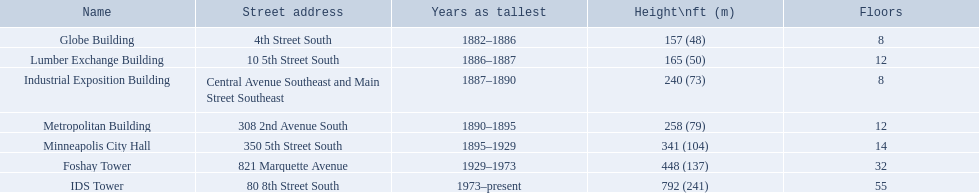What are all the building names? Globe Building, Lumber Exchange Building, Industrial Exposition Building, Metropolitan Building, Minneapolis City Hall, Foshay Tower, IDS Tower. And their heights? 157 (48), 165 (50), 240 (73), 258 (79), 341 (104), 448 (137), 792 (241). Between metropolitan building and lumber exchange building, which is taller? Metropolitan Building. 